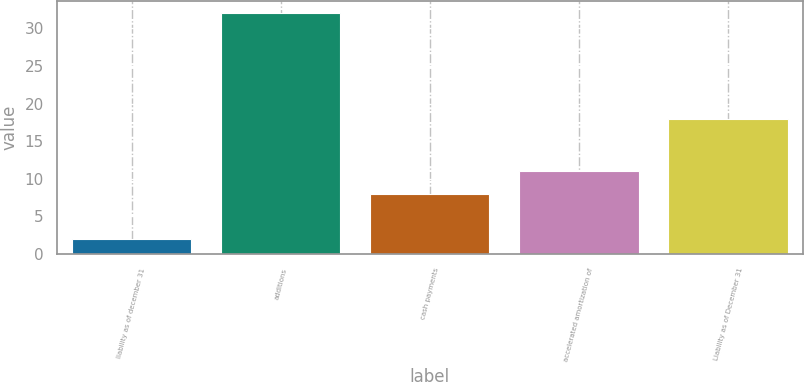Convert chart to OTSL. <chart><loc_0><loc_0><loc_500><loc_500><bar_chart><fcel>liability as of december 31<fcel>additions<fcel>cash payments<fcel>accelerated amortization of<fcel>Liability as of December 31<nl><fcel>2<fcel>32<fcel>8<fcel>11<fcel>18<nl></chart> 